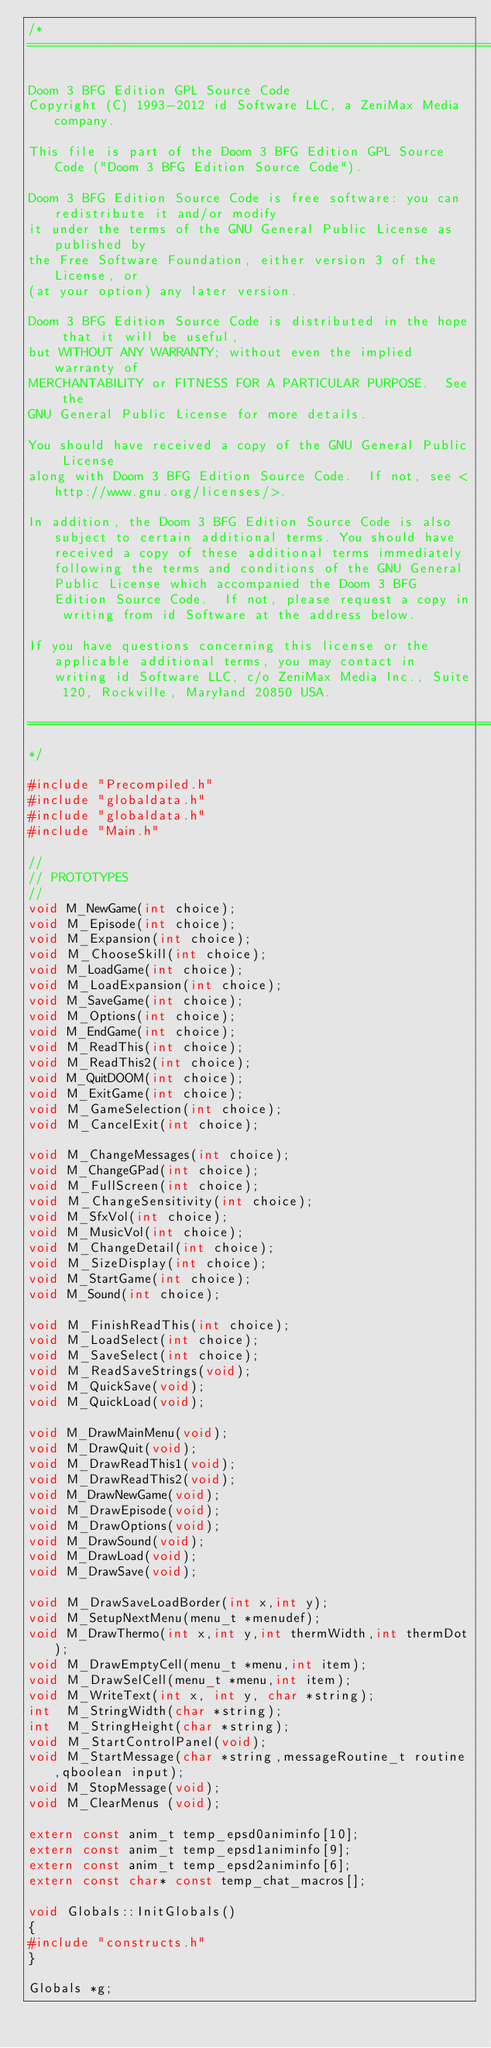<code> <loc_0><loc_0><loc_500><loc_500><_C++_>/*
===========================================================================

Doom 3 BFG Edition GPL Source Code
Copyright (C) 1993-2012 id Software LLC, a ZeniMax Media company. 

This file is part of the Doom 3 BFG Edition GPL Source Code ("Doom 3 BFG Edition Source Code").  

Doom 3 BFG Edition Source Code is free software: you can redistribute it and/or modify
it under the terms of the GNU General Public License as published by
the Free Software Foundation, either version 3 of the License, or
(at your option) any later version.

Doom 3 BFG Edition Source Code is distributed in the hope that it will be useful,
but WITHOUT ANY WARRANTY; without even the implied warranty of
MERCHANTABILITY or FITNESS FOR A PARTICULAR PURPOSE.  See the
GNU General Public License for more details.

You should have received a copy of the GNU General Public License
along with Doom 3 BFG Edition Source Code.  If not, see <http://www.gnu.org/licenses/>.

In addition, the Doom 3 BFG Edition Source Code is also subject to certain additional terms. You should have received a copy of these additional terms immediately following the terms and conditions of the GNU General Public License which accompanied the Doom 3 BFG Edition Source Code.  If not, please request a copy in writing from id Software at the address below.

If you have questions concerning this license or the applicable additional terms, you may contact in writing id Software LLC, c/o ZeniMax Media Inc., Suite 120, Rockville, Maryland 20850 USA.

===========================================================================
*/

#include "Precompiled.h"
#include "globaldata.h"
#include "globaldata.h"
#include "Main.h"

//
// PROTOTYPES
//
void M_NewGame(int choice);
void M_Episode(int choice);
void M_Expansion(int choice);
void M_ChooseSkill(int choice);
void M_LoadGame(int choice);
void M_LoadExpansion(int choice);
void M_SaveGame(int choice);
void M_Options(int choice);
void M_EndGame(int choice);
void M_ReadThis(int choice);
void M_ReadThis2(int choice);
void M_QuitDOOM(int choice);
void M_ExitGame(int choice);
void M_GameSelection(int choice);
void M_CancelExit(int choice);

void M_ChangeMessages(int choice);
void M_ChangeGPad(int choice);
void M_FullScreen(int choice);
void M_ChangeSensitivity(int choice);
void M_SfxVol(int choice);
void M_MusicVol(int choice);
void M_ChangeDetail(int choice);
void M_SizeDisplay(int choice);
void M_StartGame(int choice);
void M_Sound(int choice);

void M_FinishReadThis(int choice);
void M_LoadSelect(int choice);
void M_SaveSelect(int choice);
void M_ReadSaveStrings(void);
void M_QuickSave(void);
void M_QuickLoad(void);

void M_DrawMainMenu(void);
void M_DrawQuit(void);
void M_DrawReadThis1(void);
void M_DrawReadThis2(void);
void M_DrawNewGame(void);
void M_DrawEpisode(void);
void M_DrawOptions(void);
void M_DrawSound(void);
void M_DrawLoad(void);
void M_DrawSave(void);

void M_DrawSaveLoadBorder(int x,int y);
void M_SetupNextMenu(menu_t *menudef);
void M_DrawThermo(int x,int y,int thermWidth,int thermDot);
void M_DrawEmptyCell(menu_t *menu,int item);
void M_DrawSelCell(menu_t *menu,int item);
void M_WriteText(int x, int y, char *string);
int  M_StringWidth(char *string);
int  M_StringHeight(char *string);
void M_StartControlPanel(void);
void M_StartMessage(char *string,messageRoutine_t routine,qboolean input);
void M_StopMessage(void);
void M_ClearMenus (void);

extern const anim_t temp_epsd0animinfo[10];
extern const anim_t temp_epsd1animinfo[9];
extern const anim_t temp_epsd2animinfo[6];
extern const char* const temp_chat_macros[];

void Globals::InitGlobals()
{
#include "constructs.h"
}

Globals *g;

</code> 